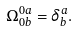Convert formula to latex. <formula><loc_0><loc_0><loc_500><loc_500>\Omega _ { 0 b } ^ { 0 a } = \delta _ { b } ^ { a } .</formula> 